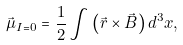Convert formula to latex. <formula><loc_0><loc_0><loc_500><loc_500>\vec { \mu } _ { I = 0 } = \frac { 1 } { 2 } \int { \left ( { \vec { r } \times \vec { B } } \right ) d ^ { 3 } x } ,</formula> 